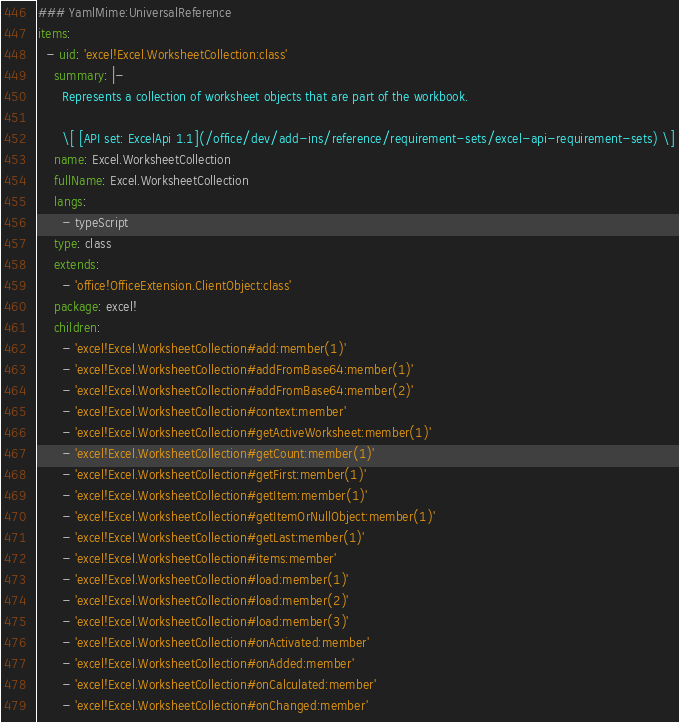Convert code to text. <code><loc_0><loc_0><loc_500><loc_500><_YAML_>### YamlMime:UniversalReference
items:
  - uid: 'excel!Excel.WorksheetCollection:class'
    summary: |-
      Represents a collection of worksheet objects that are part of the workbook.

      \[ [API set: ExcelApi 1.1](/office/dev/add-ins/reference/requirement-sets/excel-api-requirement-sets) \]
    name: Excel.WorksheetCollection
    fullName: Excel.WorksheetCollection
    langs:
      - typeScript
    type: class
    extends:
      - 'office!OfficeExtension.ClientObject:class'
    package: excel!
    children:
      - 'excel!Excel.WorksheetCollection#add:member(1)'
      - 'excel!Excel.WorksheetCollection#addFromBase64:member(1)'
      - 'excel!Excel.WorksheetCollection#addFromBase64:member(2)'
      - 'excel!Excel.WorksheetCollection#context:member'
      - 'excel!Excel.WorksheetCollection#getActiveWorksheet:member(1)'
      - 'excel!Excel.WorksheetCollection#getCount:member(1)'
      - 'excel!Excel.WorksheetCollection#getFirst:member(1)'
      - 'excel!Excel.WorksheetCollection#getItem:member(1)'
      - 'excel!Excel.WorksheetCollection#getItemOrNullObject:member(1)'
      - 'excel!Excel.WorksheetCollection#getLast:member(1)'
      - 'excel!Excel.WorksheetCollection#items:member'
      - 'excel!Excel.WorksheetCollection#load:member(1)'
      - 'excel!Excel.WorksheetCollection#load:member(2)'
      - 'excel!Excel.WorksheetCollection#load:member(3)'
      - 'excel!Excel.WorksheetCollection#onActivated:member'
      - 'excel!Excel.WorksheetCollection#onAdded:member'
      - 'excel!Excel.WorksheetCollection#onCalculated:member'
      - 'excel!Excel.WorksheetCollection#onChanged:member'</code> 